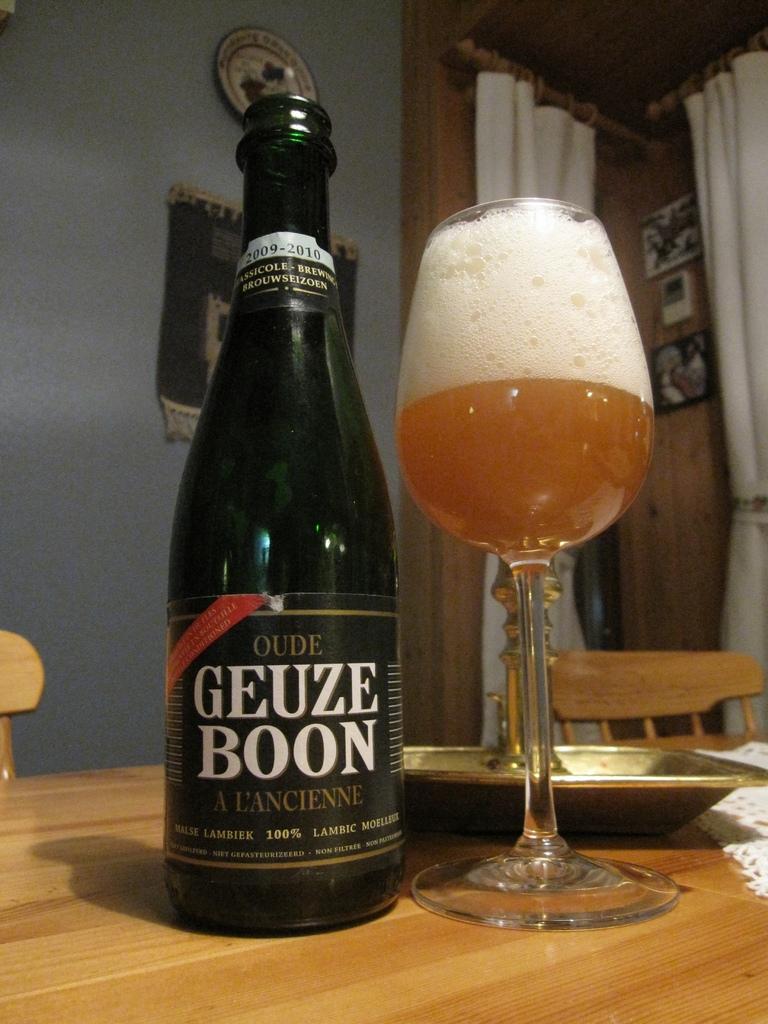What type of beer is this?
Provide a succinct answer. Geuze boon. What percent is mentioned on the bottle?
Provide a short and direct response. 100%. 